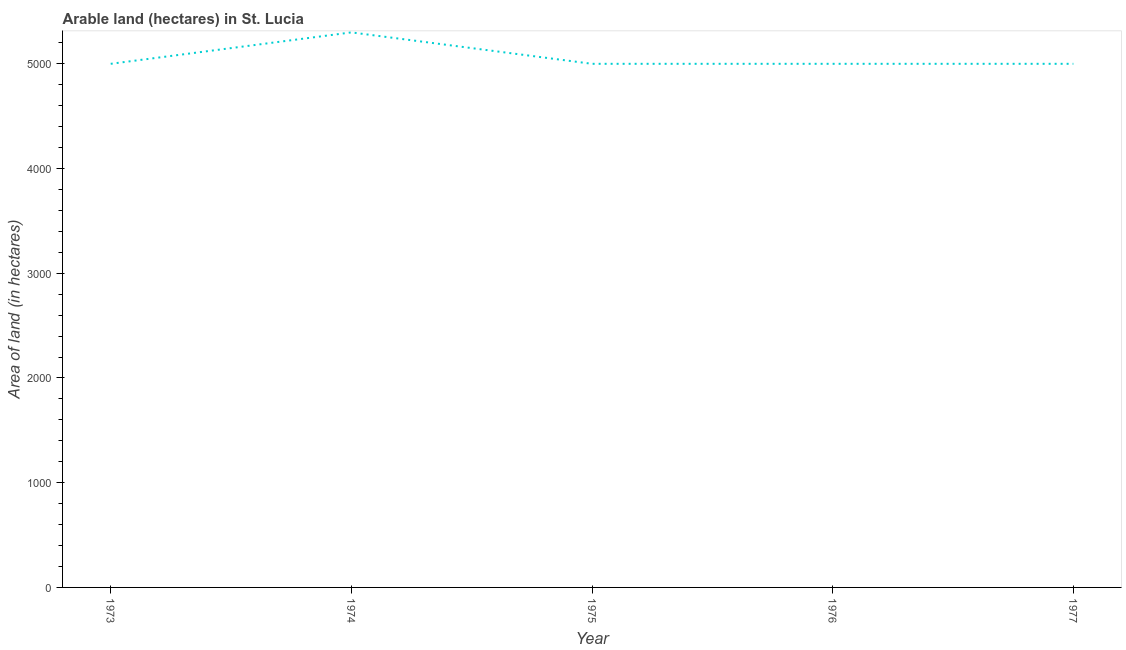What is the area of land in 1977?
Provide a short and direct response. 5000. Across all years, what is the maximum area of land?
Provide a short and direct response. 5300. Across all years, what is the minimum area of land?
Provide a short and direct response. 5000. In which year was the area of land maximum?
Give a very brief answer. 1974. What is the sum of the area of land?
Offer a terse response. 2.53e+04. What is the average area of land per year?
Provide a short and direct response. 5060. What is the median area of land?
Give a very brief answer. 5000. In how many years, is the area of land greater than 4800 hectares?
Give a very brief answer. 5. Is the area of land in 1976 less than that in 1977?
Offer a terse response. No. What is the difference between the highest and the second highest area of land?
Keep it short and to the point. 300. Is the sum of the area of land in 1973 and 1974 greater than the maximum area of land across all years?
Provide a short and direct response. Yes. What is the difference between the highest and the lowest area of land?
Make the answer very short. 300. In how many years, is the area of land greater than the average area of land taken over all years?
Provide a short and direct response. 1. Does the area of land monotonically increase over the years?
Provide a succinct answer. No. Are the values on the major ticks of Y-axis written in scientific E-notation?
Offer a terse response. No. Does the graph contain any zero values?
Make the answer very short. No. Does the graph contain grids?
Your answer should be very brief. No. What is the title of the graph?
Offer a terse response. Arable land (hectares) in St. Lucia. What is the label or title of the Y-axis?
Your response must be concise. Area of land (in hectares). What is the Area of land (in hectares) in 1974?
Your answer should be compact. 5300. What is the Area of land (in hectares) in 1975?
Your answer should be compact. 5000. What is the Area of land (in hectares) of 1977?
Make the answer very short. 5000. What is the difference between the Area of land (in hectares) in 1973 and 1974?
Provide a succinct answer. -300. What is the difference between the Area of land (in hectares) in 1973 and 1975?
Give a very brief answer. 0. What is the difference between the Area of land (in hectares) in 1973 and 1976?
Offer a very short reply. 0. What is the difference between the Area of land (in hectares) in 1973 and 1977?
Provide a succinct answer. 0. What is the difference between the Area of land (in hectares) in 1974 and 1975?
Make the answer very short. 300. What is the difference between the Area of land (in hectares) in 1974 and 1976?
Give a very brief answer. 300. What is the difference between the Area of land (in hectares) in 1974 and 1977?
Make the answer very short. 300. What is the difference between the Area of land (in hectares) in 1975 and 1977?
Keep it short and to the point. 0. What is the ratio of the Area of land (in hectares) in 1973 to that in 1974?
Make the answer very short. 0.94. What is the ratio of the Area of land (in hectares) in 1973 to that in 1975?
Your answer should be very brief. 1. What is the ratio of the Area of land (in hectares) in 1974 to that in 1975?
Your answer should be compact. 1.06. What is the ratio of the Area of land (in hectares) in 1974 to that in 1976?
Keep it short and to the point. 1.06. What is the ratio of the Area of land (in hectares) in 1974 to that in 1977?
Keep it short and to the point. 1.06. What is the ratio of the Area of land (in hectares) in 1975 to that in 1976?
Your answer should be very brief. 1. What is the ratio of the Area of land (in hectares) in 1976 to that in 1977?
Offer a very short reply. 1. 